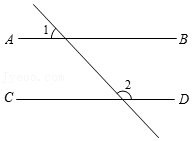What if another line, GH, is perpendicular to AB and intersects CD, what would the measure of the angle formed at the intersection with CD be? If line GH is perpendicular to AB, then it forms a 90° angle with line AB. Since AB and CD are parallel, line GH will also form a 90° angle at the point of intersection with line CD, demonstrating the consistency of perpendicular lines intersecting parallel lines. 